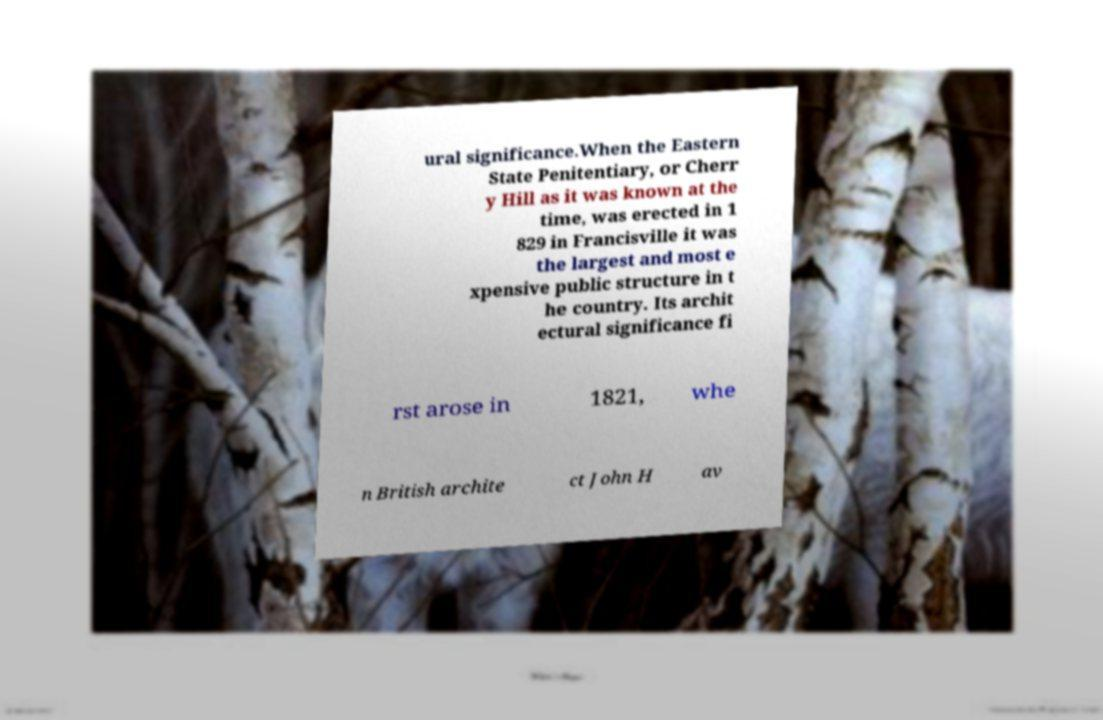Please read and relay the text visible in this image. What does it say? ural significance.When the Eastern State Penitentiary, or Cherr y Hill as it was known at the time, was erected in 1 829 in Francisville it was the largest and most e xpensive public structure in t he country. Its archit ectural significance fi rst arose in 1821, whe n British archite ct John H av 